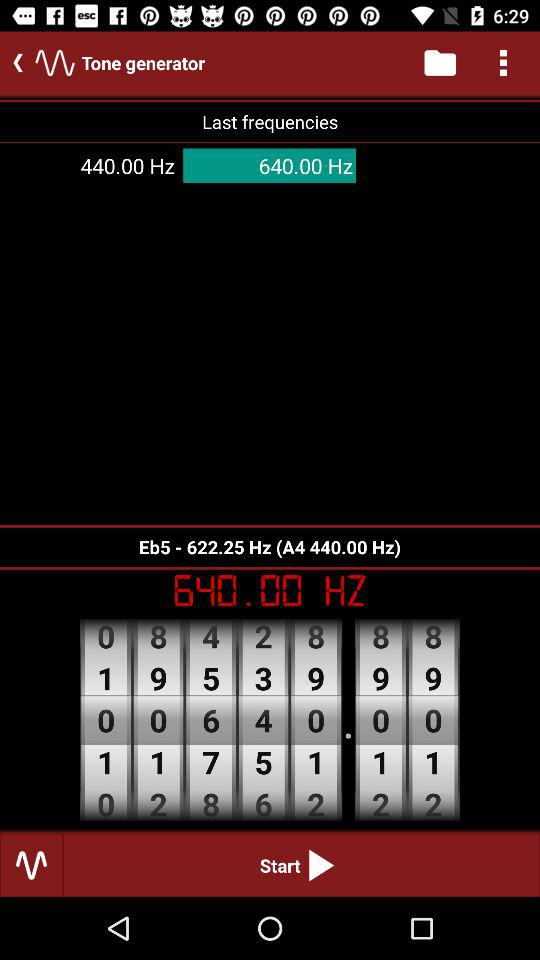What is the Eb5 frequency? The Eb5 frequency is 622.25 Hz. 